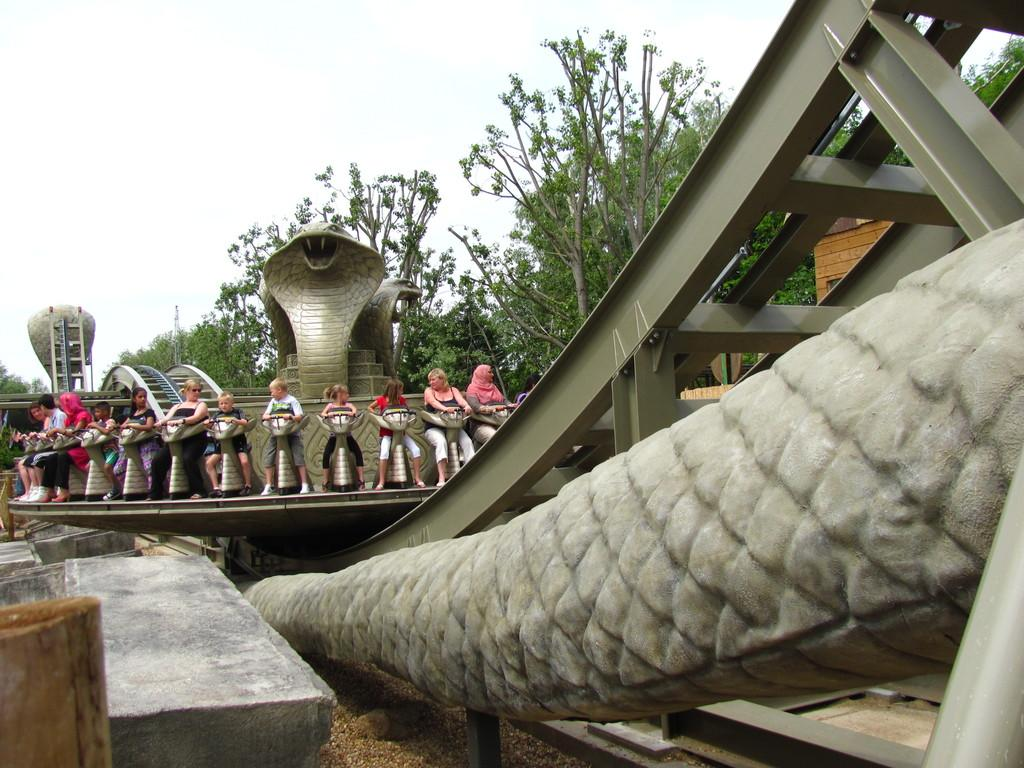What is happening in the image involving the people? The people are taking an amusement ride. What can be seen in the background of the image? There are trees visible in the image. What type of worm can be seen crawling on the people in the image? There are no worms present in the image; it features people taking an amusement ride with trees in the background. 